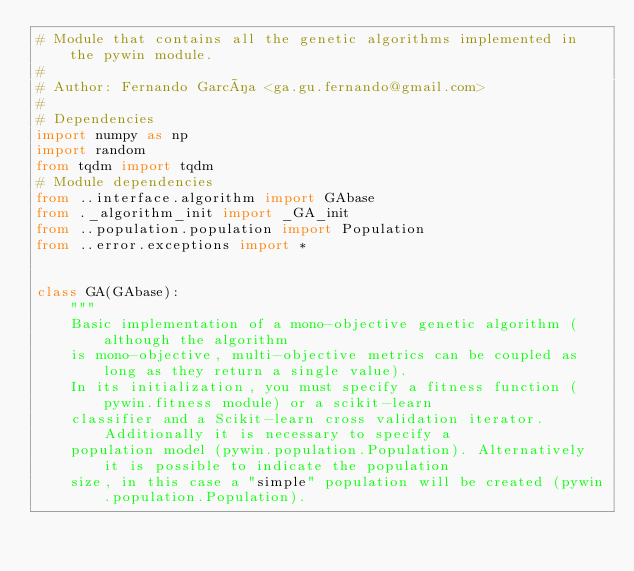<code> <loc_0><loc_0><loc_500><loc_500><_Python_># Module that contains all the genetic algorithms implemented in the pywin module.
#
# Author: Fernando García <ga.gu.fernando@gmail.com>
#
# Dependencies
import numpy as np
import random
from tqdm import tqdm
# Module dependencies
from ..interface.algorithm import GAbase
from ._algorithm_init import _GA_init
from ..population.population import Population
from ..error.exceptions import *


class GA(GAbase):
    """
    Basic implementation of a mono-objective genetic algorithm (although the algorithm
    is mono-objective, multi-objective metrics can be coupled as long as they return a single value).
    In its initialization, you must specify a fitness function (pywin.fitness module) or a scikit-learn
    classifier and a Scikit-learn cross validation iterator. Additionally it is necessary to specify a
    population model (pywin.population.Population). Alternatively it is possible to indicate the population
    size, in this case a "simple" population will be created (pywin.population.Population).</code> 